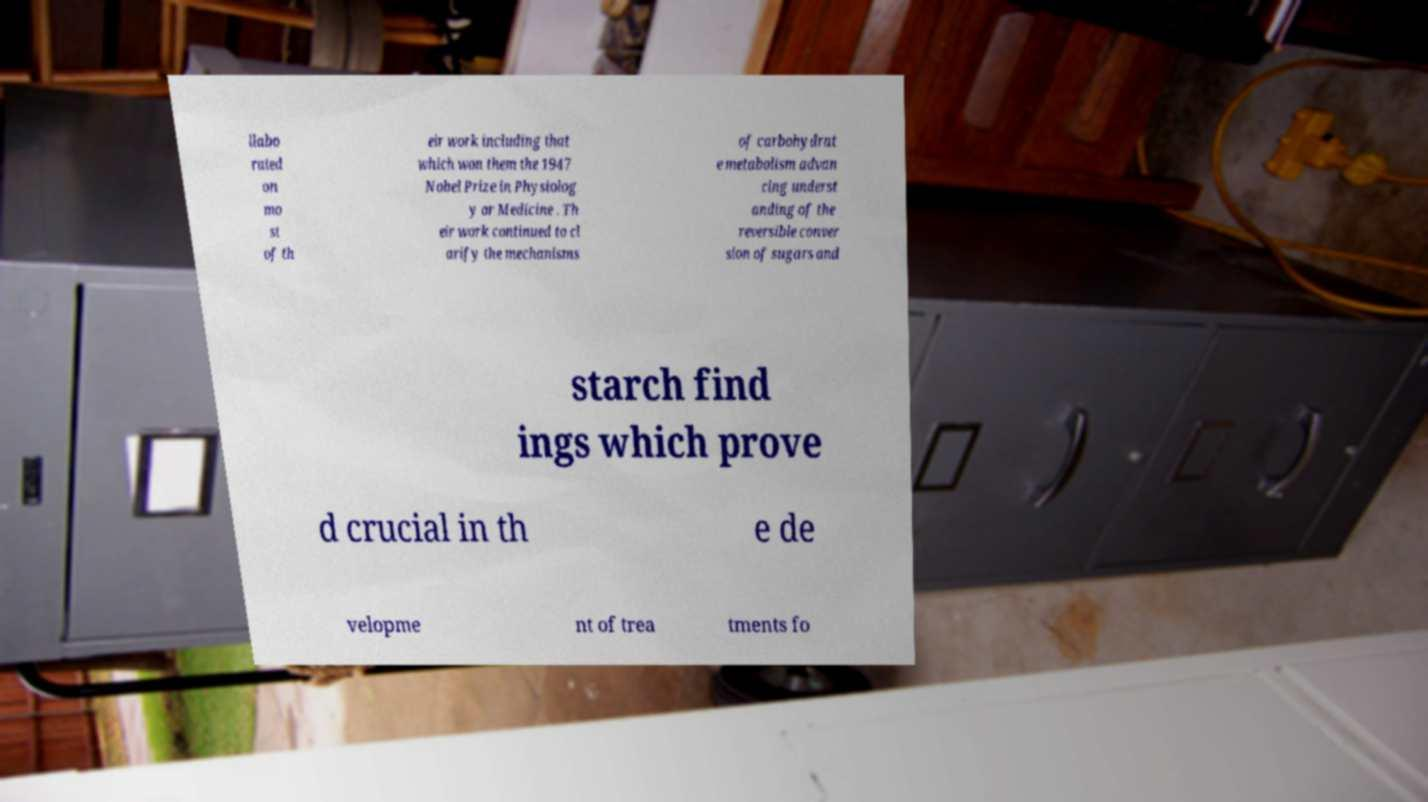What messages or text are displayed in this image? I need them in a readable, typed format. llabo rated on mo st of th eir work including that which won them the 1947 Nobel Prize in Physiolog y or Medicine . Th eir work continued to cl arify the mechanisms of carbohydrat e metabolism advan cing underst anding of the reversible conver sion of sugars and starch find ings which prove d crucial in th e de velopme nt of trea tments fo 